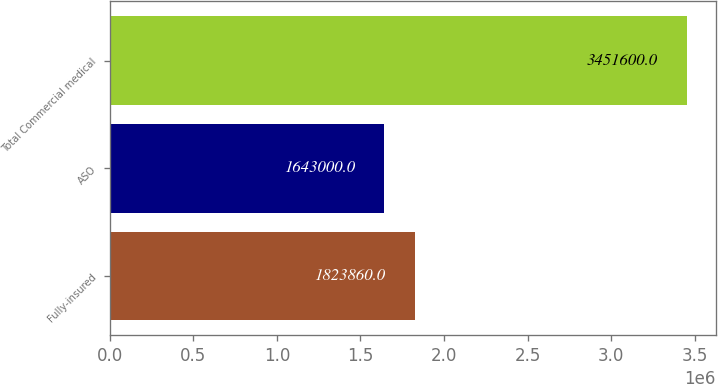<chart> <loc_0><loc_0><loc_500><loc_500><bar_chart><fcel>Fully-insured<fcel>ASO<fcel>Total Commercial medical<nl><fcel>1.82386e+06<fcel>1.643e+06<fcel>3.4516e+06<nl></chart> 